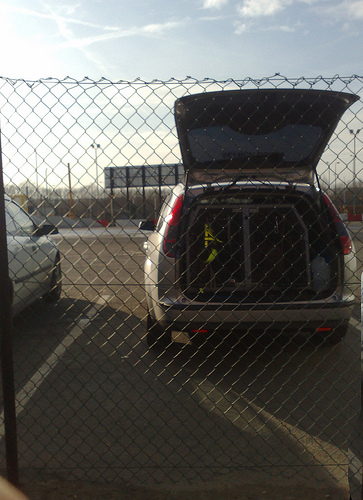<image>
Can you confirm if the gate is in the car? No. The gate is not contained within the car. These objects have a different spatial relationship. 